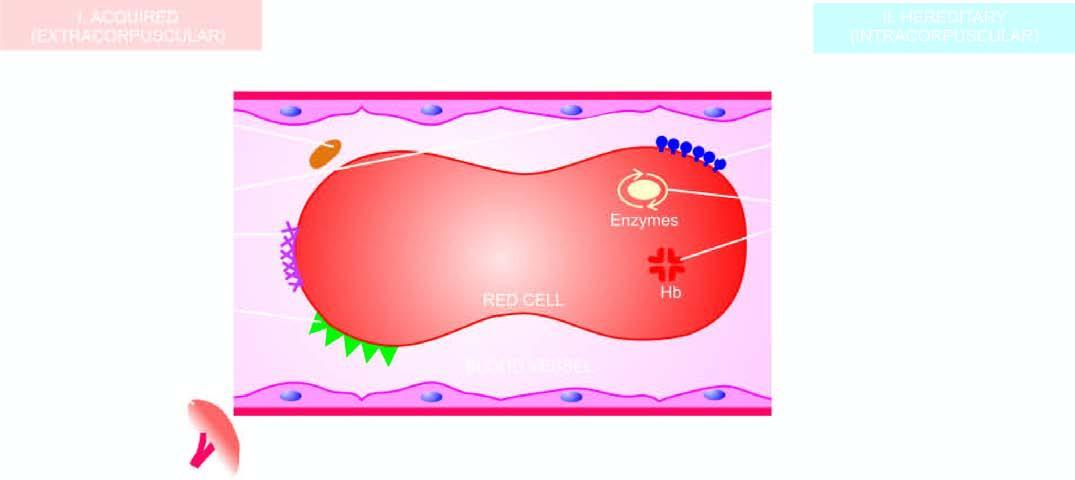re the congophilic areas based on principal mechanisms of haemolysis?
Answer the question using a single word or phrase. No 